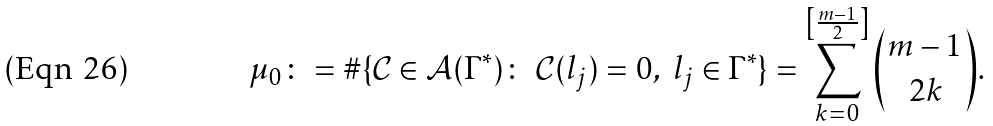Convert formula to latex. <formula><loc_0><loc_0><loc_500><loc_500>\mu _ { 0 } \colon = \# \{ \mathcal { C } \in \mathcal { A } ( \Gamma ^ { * } ) \colon \ \mathcal { C } ( l _ { j } ) = 0 , \ l _ { j } \in \Gamma ^ { * } \} = \sum _ { k = 0 } ^ { \left [ \frac { m - 1 } { 2 } \right ] } { m - 1 \choose 2 k } .</formula> 